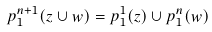Convert formula to latex. <formula><loc_0><loc_0><loc_500><loc_500>p _ { 1 } ^ { n + 1 } ( z \cup w ) = p _ { 1 } ^ { 1 } ( z ) \cup p _ { 1 } ^ { n } ( w )</formula> 